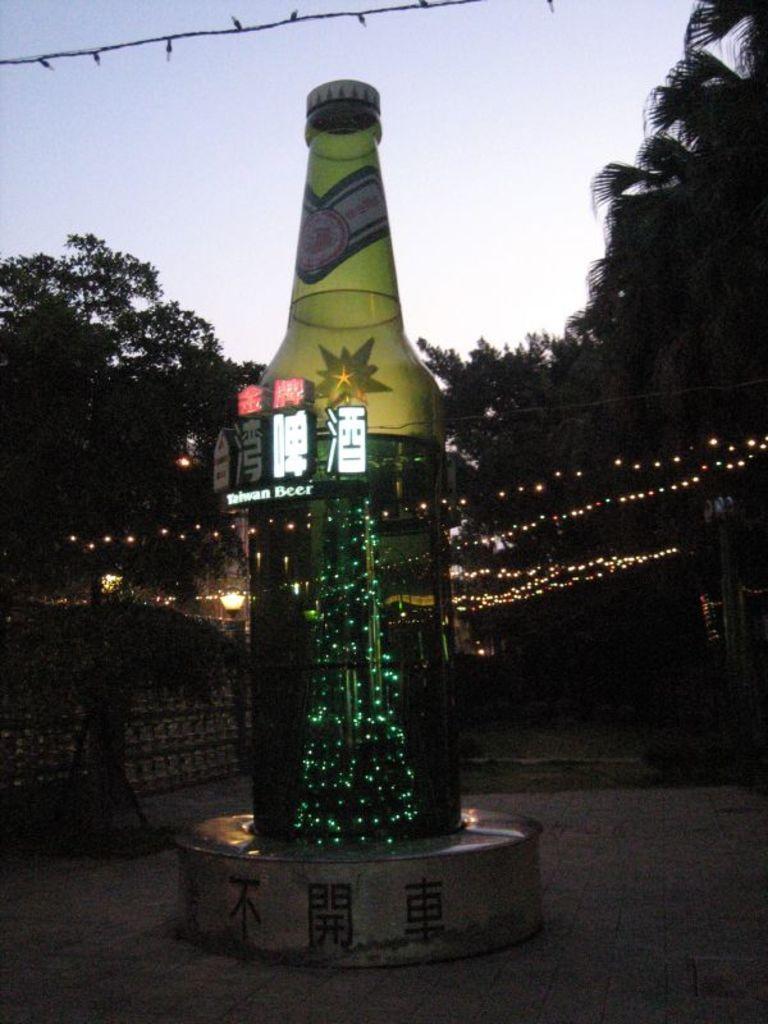In one or two sentences, can you explain what this image depicts? There is a big bottle like structure. In it a Christmas tree is illuminated with lights. The surrounding area is decorated with series lights. There are some trees in the background. 